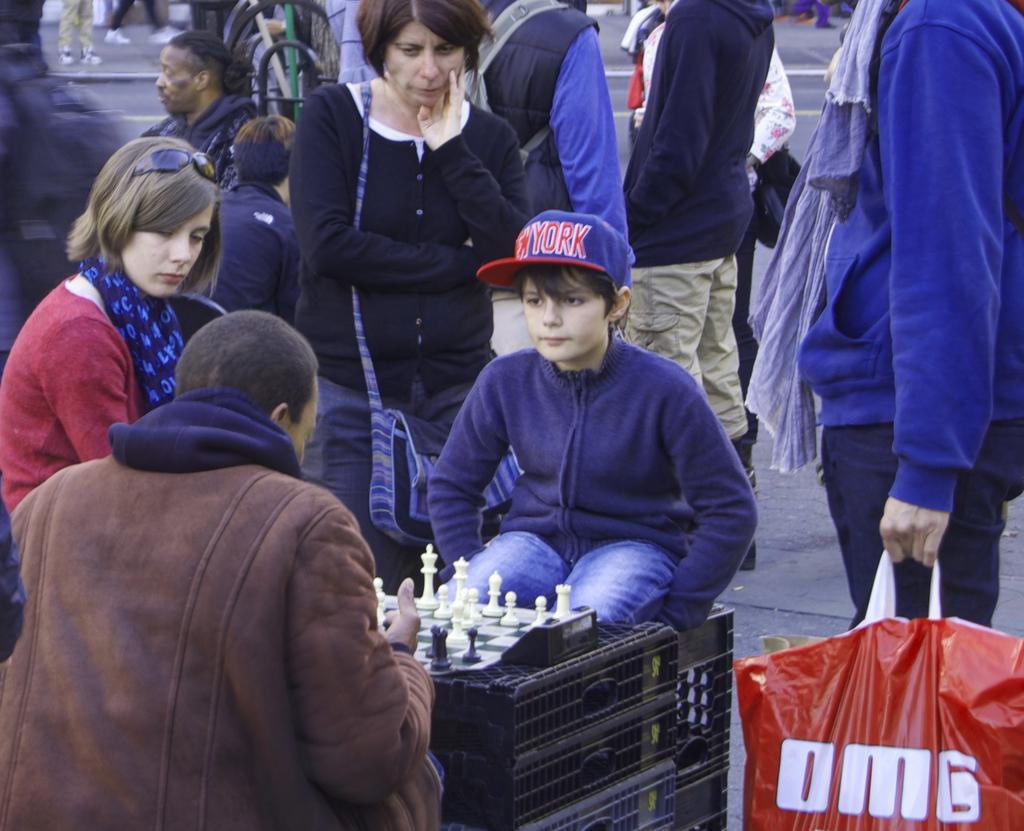In one or two sentences, can you explain what this image depicts? In this picture we observe many people are on the road and there are two people playing chess. 